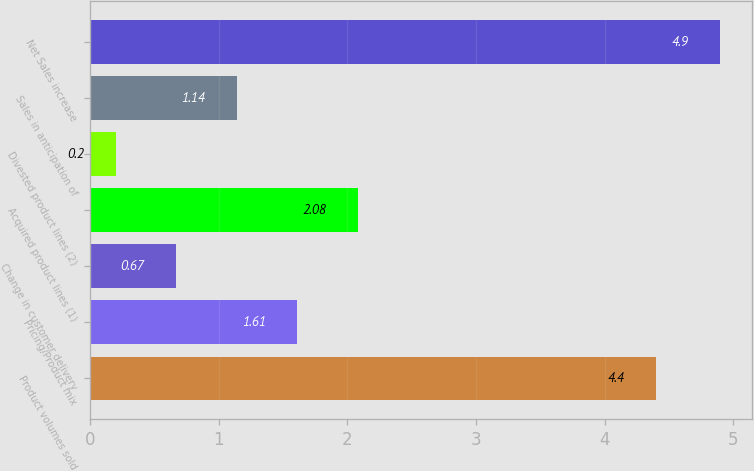<chart> <loc_0><loc_0><loc_500><loc_500><bar_chart><fcel>Product volumes sold<fcel>Pricing/Product mix<fcel>Change in customer delivery<fcel>Acquired product lines (1)<fcel>Divested product lines (2)<fcel>Sales in anticipation of<fcel>Net Sales increase<nl><fcel>4.4<fcel>1.61<fcel>0.67<fcel>2.08<fcel>0.2<fcel>1.14<fcel>4.9<nl></chart> 